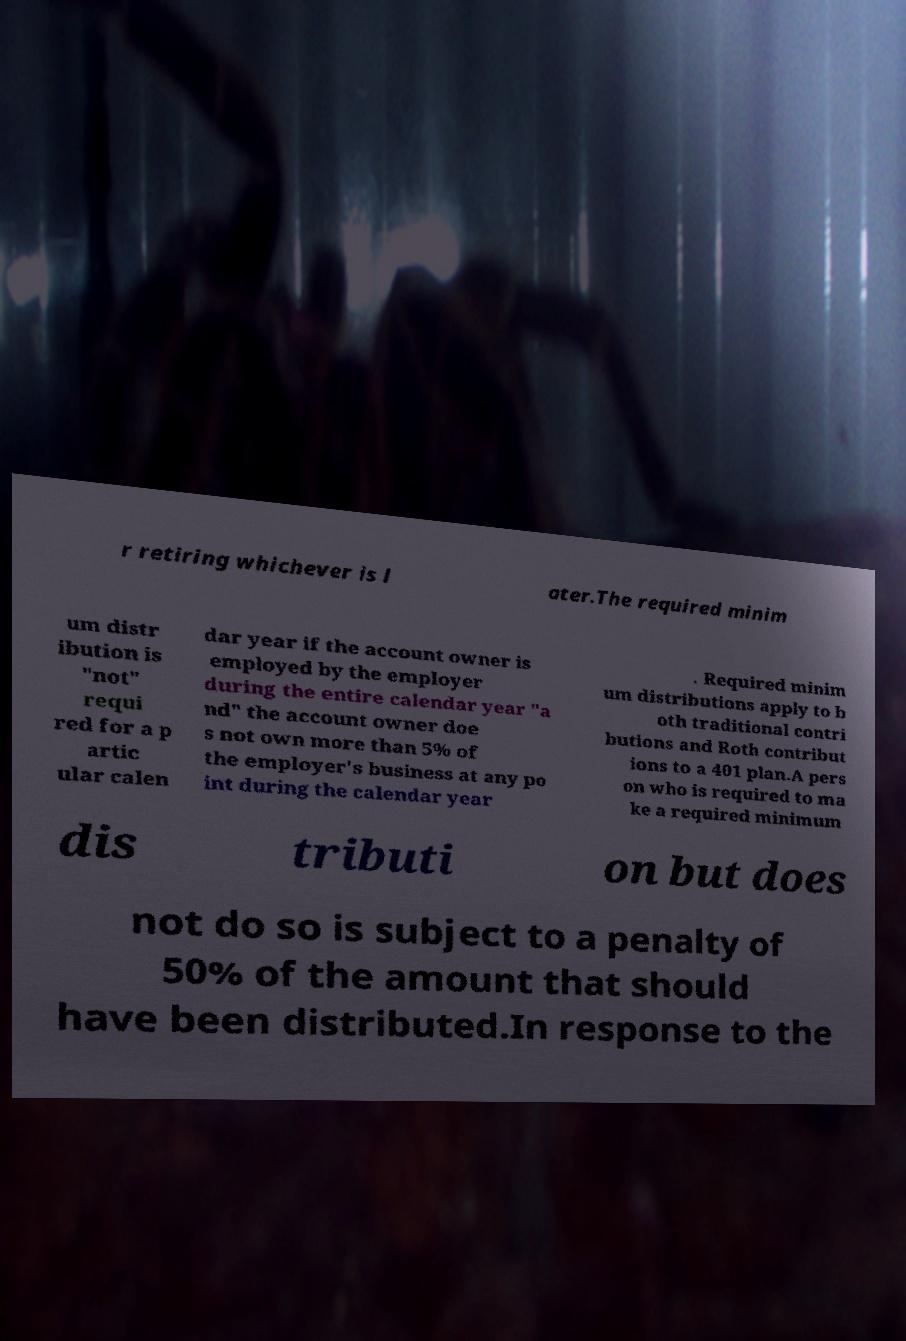Please identify and transcribe the text found in this image. r retiring whichever is l ater.The required minim um distr ibution is "not" requi red for a p artic ular calen dar year if the account owner is employed by the employer during the entire calendar year "a nd" the account owner doe s not own more than 5% of the employer's business at any po int during the calendar year . Required minim um distributions apply to b oth traditional contri butions and Roth contribut ions to a 401 plan.A pers on who is required to ma ke a required minimum dis tributi on but does not do so is subject to a penalty of 50% of the amount that should have been distributed.In response to the 